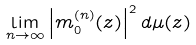<formula> <loc_0><loc_0><loc_500><loc_500>\lim _ { n \rightarrow \infty } \left | m _ { 0 } ^ { ( n ) } ( z ) \right | ^ { 2 } d \mu ( z )</formula> 